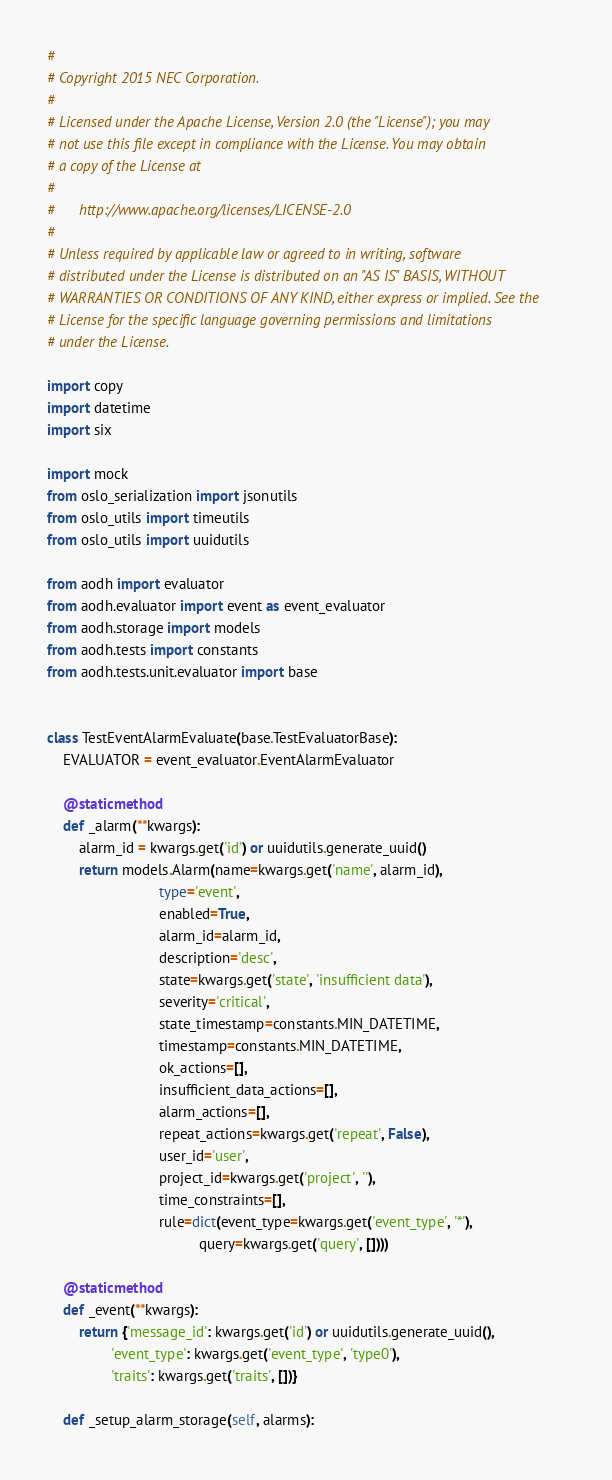Convert code to text. <code><loc_0><loc_0><loc_500><loc_500><_Python_>#
# Copyright 2015 NEC Corporation.
#
# Licensed under the Apache License, Version 2.0 (the "License"); you may
# not use this file except in compliance with the License. You may obtain
# a copy of the License at
#
#      http://www.apache.org/licenses/LICENSE-2.0
#
# Unless required by applicable law or agreed to in writing, software
# distributed under the License is distributed on an "AS IS" BASIS, WITHOUT
# WARRANTIES OR CONDITIONS OF ANY KIND, either express or implied. See the
# License for the specific language governing permissions and limitations
# under the License.

import copy
import datetime
import six

import mock
from oslo_serialization import jsonutils
from oslo_utils import timeutils
from oslo_utils import uuidutils

from aodh import evaluator
from aodh.evaluator import event as event_evaluator
from aodh.storage import models
from aodh.tests import constants
from aodh.tests.unit.evaluator import base


class TestEventAlarmEvaluate(base.TestEvaluatorBase):
    EVALUATOR = event_evaluator.EventAlarmEvaluator

    @staticmethod
    def _alarm(**kwargs):
        alarm_id = kwargs.get('id') or uuidutils.generate_uuid()
        return models.Alarm(name=kwargs.get('name', alarm_id),
                            type='event',
                            enabled=True,
                            alarm_id=alarm_id,
                            description='desc',
                            state=kwargs.get('state', 'insufficient data'),
                            severity='critical',
                            state_timestamp=constants.MIN_DATETIME,
                            timestamp=constants.MIN_DATETIME,
                            ok_actions=[],
                            insufficient_data_actions=[],
                            alarm_actions=[],
                            repeat_actions=kwargs.get('repeat', False),
                            user_id='user',
                            project_id=kwargs.get('project', ''),
                            time_constraints=[],
                            rule=dict(event_type=kwargs.get('event_type', '*'),
                                      query=kwargs.get('query', [])))

    @staticmethod
    def _event(**kwargs):
        return {'message_id': kwargs.get('id') or uuidutils.generate_uuid(),
                'event_type': kwargs.get('event_type', 'type0'),
                'traits': kwargs.get('traits', [])}

    def _setup_alarm_storage(self, alarms):</code> 